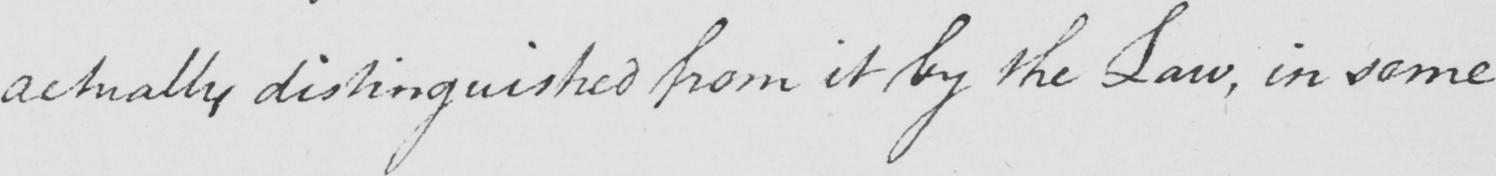What is written in this line of handwriting? actually distinguished from it by the Law , in some 